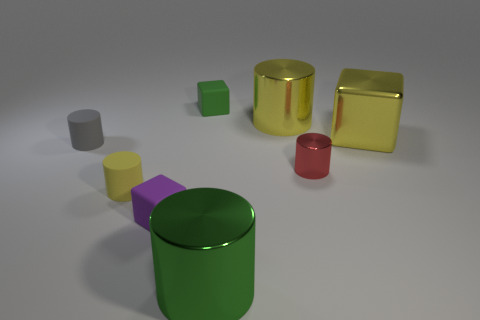Subtract all red shiny cylinders. How many cylinders are left? 4 Subtract all brown cylinders. Subtract all cyan spheres. How many cylinders are left? 5 Add 2 green rubber cubes. How many objects exist? 10 Subtract all blocks. How many objects are left? 5 Subtract all small objects. Subtract all small yellow rubber things. How many objects are left? 2 Add 1 small red shiny cylinders. How many small red shiny cylinders are left? 2 Add 8 tiny purple blocks. How many tiny purple blocks exist? 9 Subtract 0 purple cylinders. How many objects are left? 8 